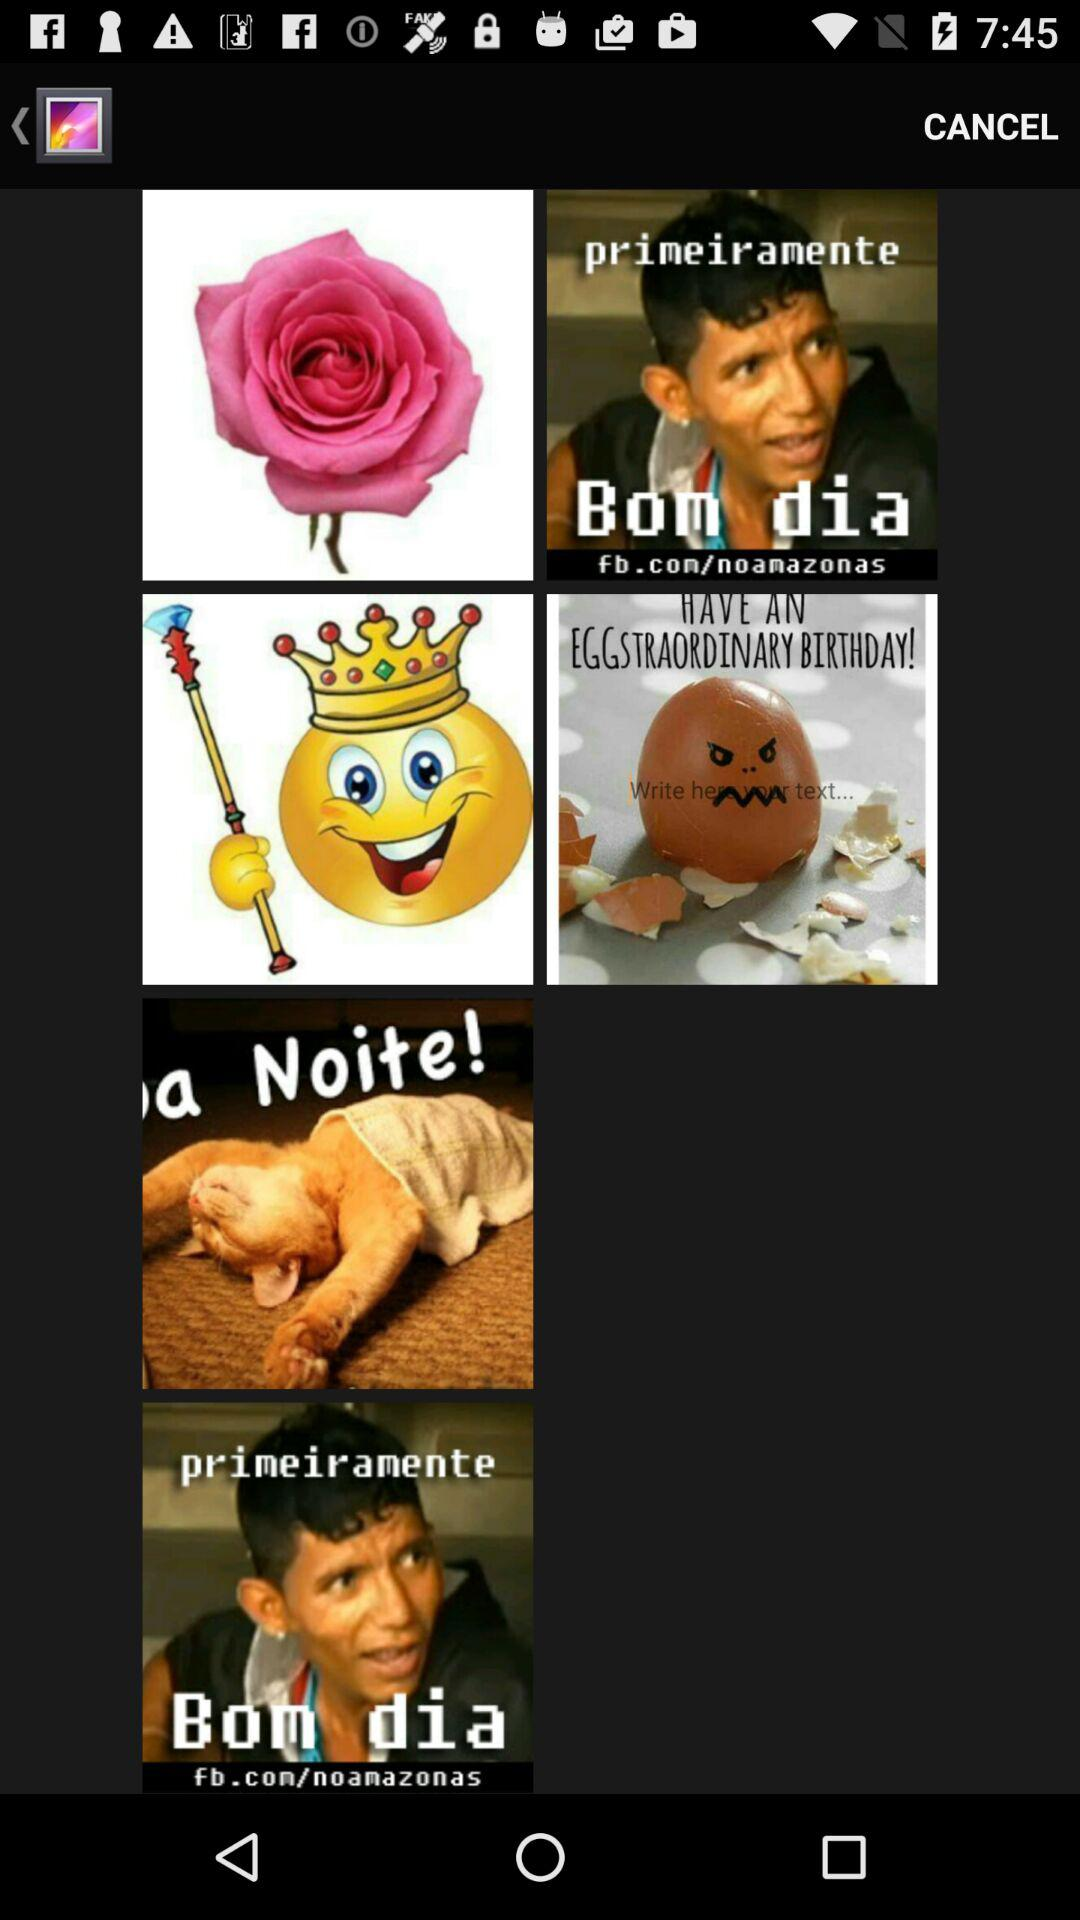How many items have a text element?
Answer the question using a single word or phrase. 4 